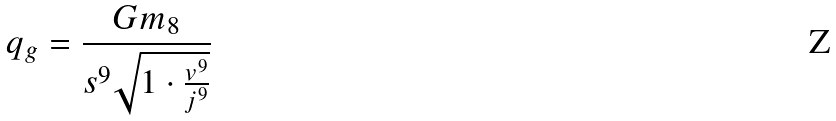<formula> <loc_0><loc_0><loc_500><loc_500>q _ { g } = \frac { G m _ { 8 } } { s ^ { 9 } \sqrt { 1 \cdot \frac { v ^ { 9 } } { j ^ { 9 } } } }</formula> 